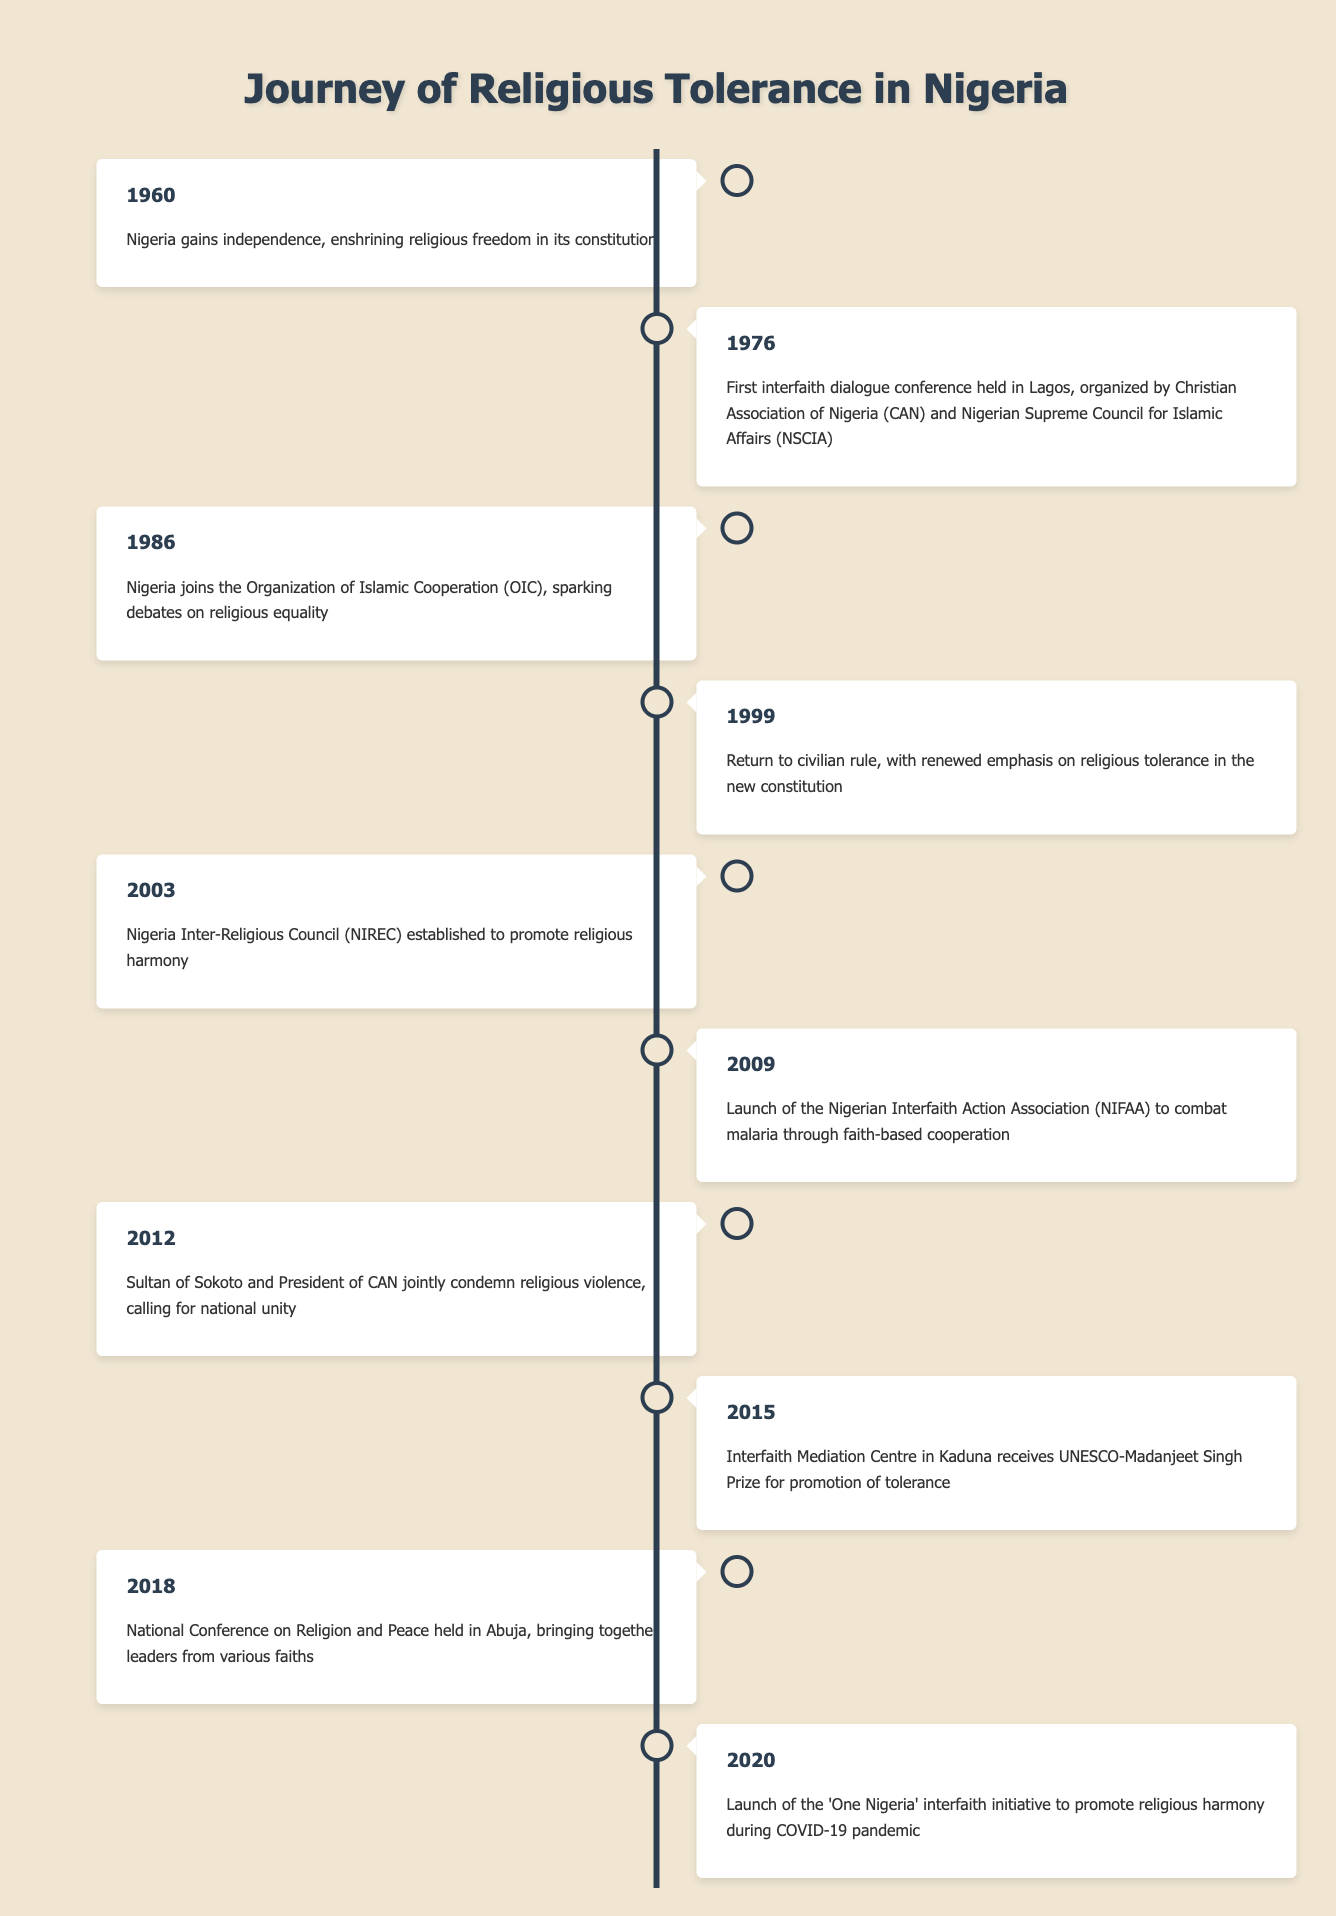What year did Nigeria gain independence? The timeline shows that Nigeria gained independence in the year 1960. This is the first event listed in the table.
Answer: 1960 What initiative was launched in 2009? In 2009, the Nigerian Interfaith Action Association (NIFAA) was launched to combat malaria through faith-based cooperation, as stated in the table.
Answer: Nigerian Interfaith Action Association (NIFAA) When was the first interfaith dialogue conference held? According to the timeline, the first interfaith dialogue conference was held in Lagos in 1976. This is explicitly mentioned in the second event listed.
Answer: 1976 Did Nigeria join the Organization of Islamic Cooperation before or after the year 2000? Referring to the table, Nigeria joined the Organization of Islamic Cooperation (OIC) in 1986, which is before the year 2000.
Answer: Before How many significant events related to religious tolerance occurred between 2000 and 2010? The timeline shows events in 2003 (NIREC established), 2009 (NIFAA launched), and events surrounding earlier years were excluded. Thus, there are two significant events in that range, one in 2003 and one in 2009.
Answer: 2 Which event in 2015 received a UNESCO award? The event in 2015 mentioned in the table is the Interfaith Mediation Centre in Kaduna receiving the UNESCO-Madanjeet Singh Prize for promotion of tolerance. This is clearly stated in the description for that year.
Answer: Interfaith Mediation Centre What is the relationship between the 2012 condemnation of religious violence and calls for national unity? In 2012, both the Sultan of Sokoto and the President of the Christian Association of Nigeria condemned religious violence together, emphasizing the importance of national unity. This indicates that the act of condemnation was related to domestic peace and inclusiveness, reflecting a cooperative stance on religious tolerance.
Answer: They are related Which year indicates a renewed emphasis on religious tolerance in Nigeria's constitution? The year 1999 indicates a renewed emphasis on religious tolerance in the new constitution following the return to civilian rule, as specified in the timeline.
Answer: 1999 How many years apart was the establishment of the Nigeria Inter-Religious Council and the interfaith dialogue conference in Lagos? The Nigeria Inter-Religious Council (NIREC) was established in 2003 and the interfaith dialogue conference was held in 1976. The years 2003 and 1976, when subtracted (2003 - 1976), give 27 years.
Answer: 27 years 